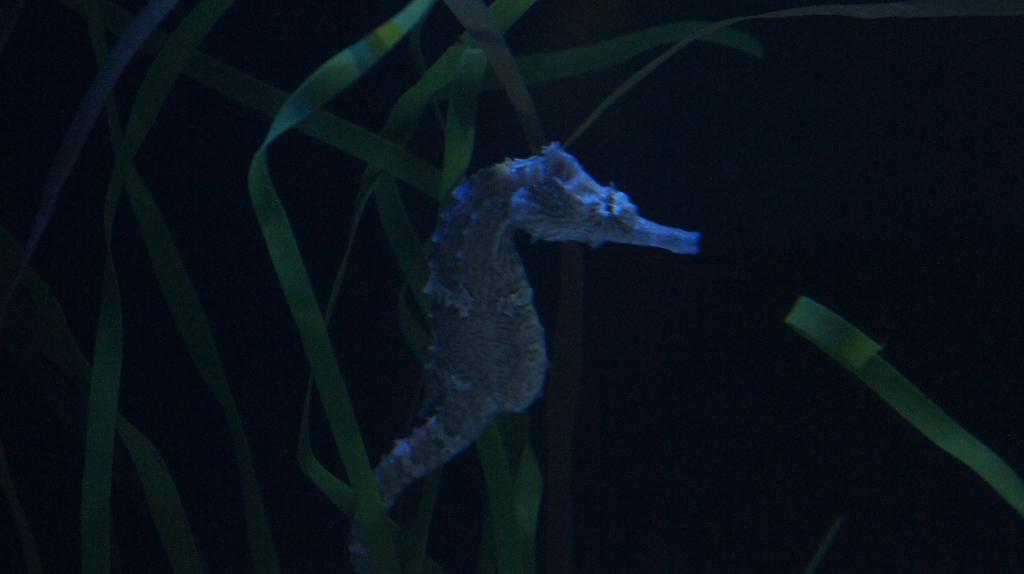In one or two sentences, can you explain what this image depicts? In the foreground of this image, there is a sea horse in the middle of the image. In the dark background, there are grass leaves. 